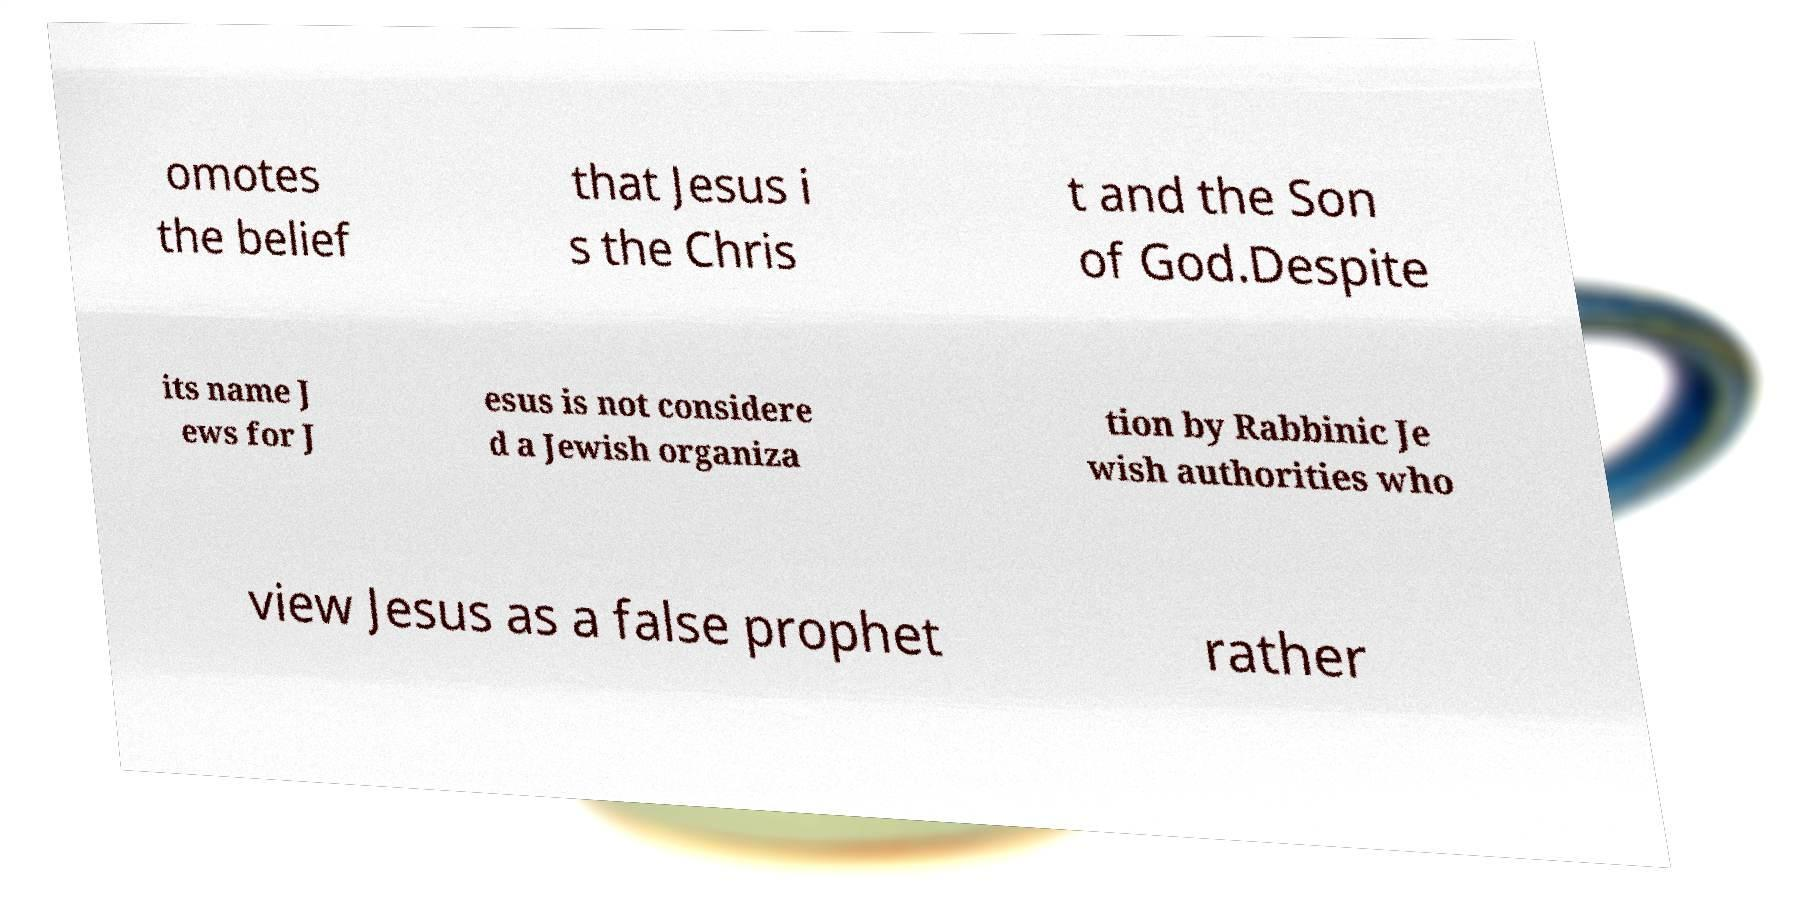Could you assist in decoding the text presented in this image and type it out clearly? omotes the belief that Jesus i s the Chris t and the Son of God.Despite its name J ews for J esus is not considere d a Jewish organiza tion by Rabbinic Je wish authorities who view Jesus as a false prophet rather 